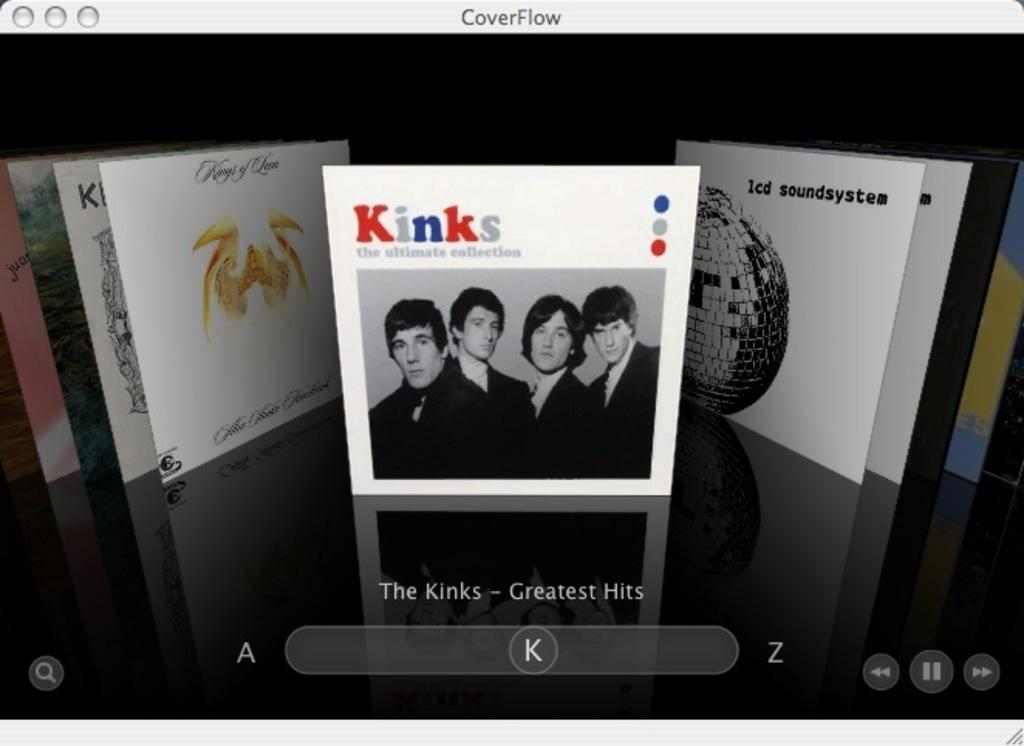What device is present in the image? There is a music player in the image. What can be seen alongside the music player? There are album cover pictures in the image. What type of crack is visible on the music player in the image? There is no crack visible on the music player in the image. What color is the orange on the album cover pictures in the image? There is no orange present on the album cover pictures in the image. 